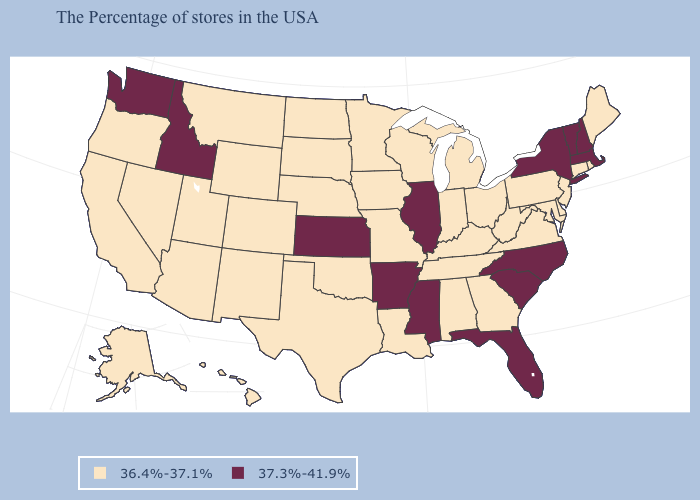Among the states that border Utah , does Idaho have the highest value?
Short answer required. Yes. Which states have the highest value in the USA?
Keep it brief. Massachusetts, New Hampshire, Vermont, New York, North Carolina, South Carolina, Florida, Illinois, Mississippi, Arkansas, Kansas, Idaho, Washington. What is the highest value in the MidWest ?
Short answer required. 37.3%-41.9%. What is the lowest value in the USA?
Keep it brief. 36.4%-37.1%. Does the first symbol in the legend represent the smallest category?
Concise answer only. Yes. Name the states that have a value in the range 37.3%-41.9%?
Be succinct. Massachusetts, New Hampshire, Vermont, New York, North Carolina, South Carolina, Florida, Illinois, Mississippi, Arkansas, Kansas, Idaho, Washington. Which states have the lowest value in the West?
Write a very short answer. Wyoming, Colorado, New Mexico, Utah, Montana, Arizona, Nevada, California, Oregon, Alaska, Hawaii. Among the states that border Minnesota , which have the lowest value?
Answer briefly. Wisconsin, Iowa, South Dakota, North Dakota. Name the states that have a value in the range 36.4%-37.1%?
Answer briefly. Maine, Rhode Island, Connecticut, New Jersey, Delaware, Maryland, Pennsylvania, Virginia, West Virginia, Ohio, Georgia, Michigan, Kentucky, Indiana, Alabama, Tennessee, Wisconsin, Louisiana, Missouri, Minnesota, Iowa, Nebraska, Oklahoma, Texas, South Dakota, North Dakota, Wyoming, Colorado, New Mexico, Utah, Montana, Arizona, Nevada, California, Oregon, Alaska, Hawaii. Does Minnesota have a lower value than Florida?
Quick response, please. Yes. Does Alabama have a higher value than Pennsylvania?
Quick response, please. No. Name the states that have a value in the range 37.3%-41.9%?
Keep it brief. Massachusetts, New Hampshire, Vermont, New York, North Carolina, South Carolina, Florida, Illinois, Mississippi, Arkansas, Kansas, Idaho, Washington. What is the value of Montana?
Be succinct. 36.4%-37.1%. What is the lowest value in states that border New Hampshire?
Keep it brief. 36.4%-37.1%. What is the highest value in states that border Iowa?
Quick response, please. 37.3%-41.9%. 